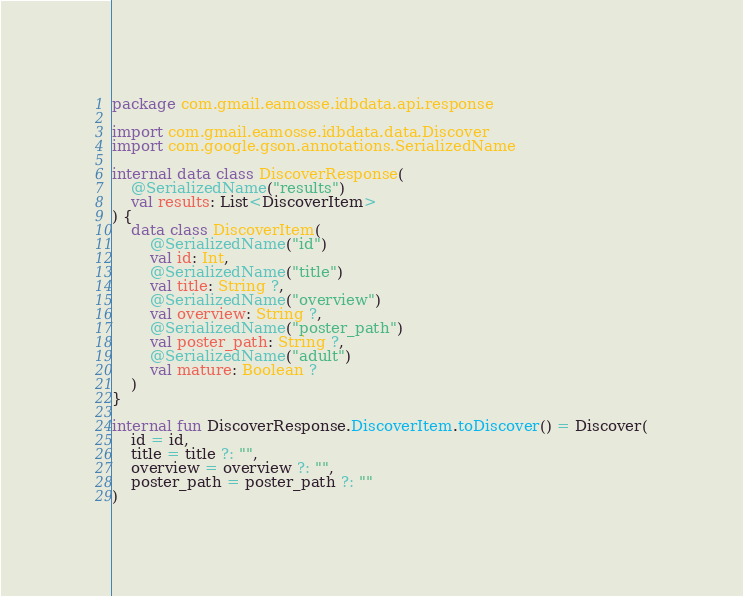<code> <loc_0><loc_0><loc_500><loc_500><_Kotlin_>package com.gmail.eamosse.idbdata.api.response

import com.gmail.eamosse.idbdata.data.Discover
import com.google.gson.annotations.SerializedName

internal data class DiscoverResponse(
    @SerializedName("results")
    val results: List<DiscoverItem>
) {
    data class DiscoverItem(
        @SerializedName("id")
        val id: Int,
        @SerializedName("title")
        val title: String ?,
        @SerializedName("overview")
        val overview: String ?,
        @SerializedName("poster_path")
        val poster_path: String ?,
        @SerializedName("adult")
        val mature: Boolean ?
    )
}

internal fun DiscoverResponse.DiscoverItem.toDiscover() = Discover(
    id = id,
    title = title ?: "",
    overview = overview ?: "",
    poster_path = poster_path ?: ""
)
</code> 